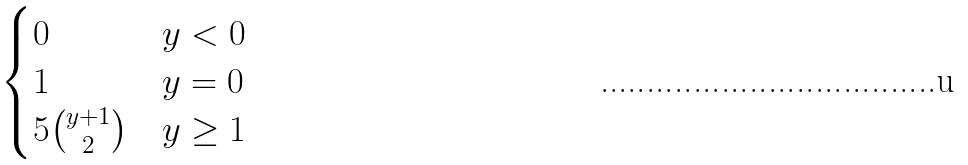<formula> <loc_0><loc_0><loc_500><loc_500>\begin{cases} 0 & y < 0 \\ 1 & y = 0 \\ 5 { y + 1 \choose 2 } & y \geq 1 \\ \end{cases}</formula> 